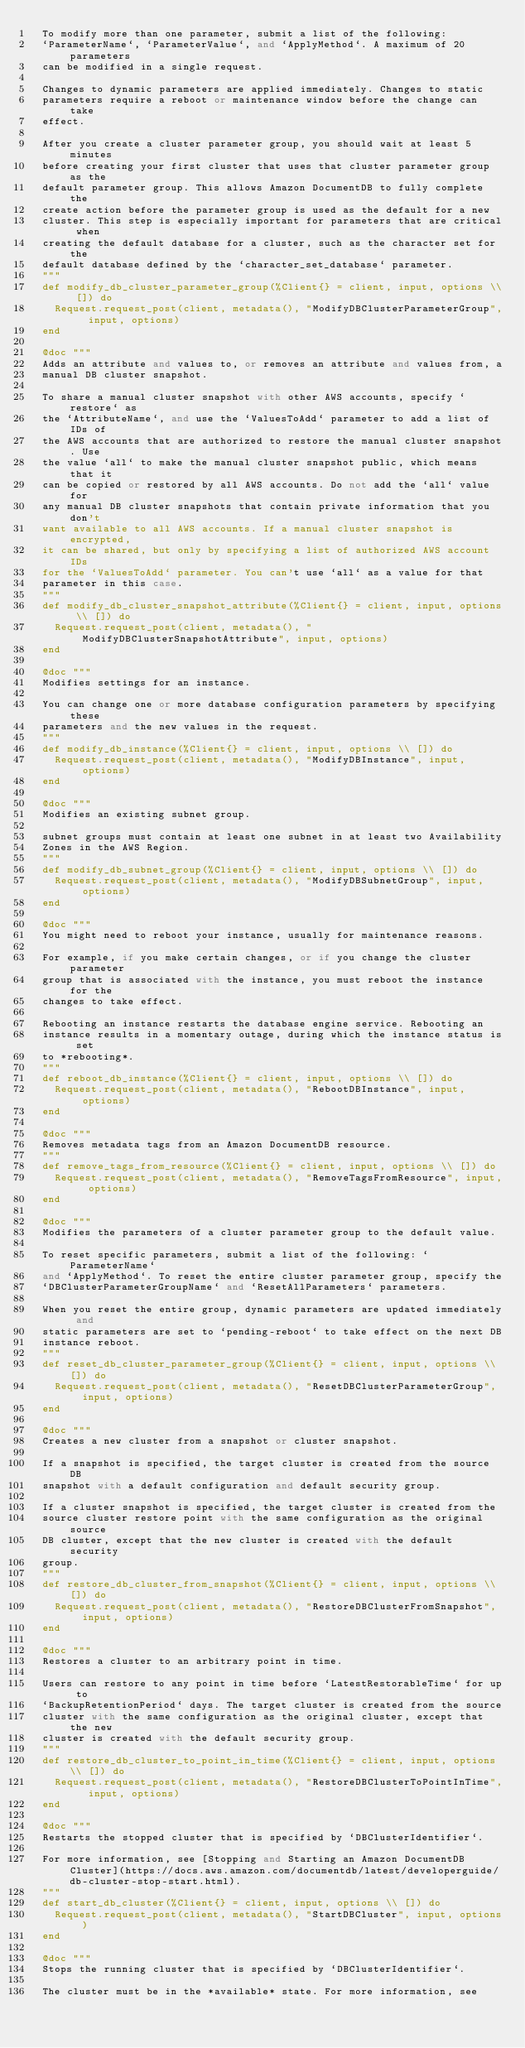Convert code to text. <code><loc_0><loc_0><loc_500><loc_500><_Elixir_>  To modify more than one parameter, submit a list of the following:
  `ParameterName`, `ParameterValue`, and `ApplyMethod`. A maximum of 20 parameters
  can be modified in a single request.

  Changes to dynamic parameters are applied immediately. Changes to static
  parameters require a reboot or maintenance window before the change can take
  effect.

  After you create a cluster parameter group, you should wait at least 5 minutes
  before creating your first cluster that uses that cluster parameter group as the
  default parameter group. This allows Amazon DocumentDB to fully complete the
  create action before the parameter group is used as the default for a new
  cluster. This step is especially important for parameters that are critical when
  creating the default database for a cluster, such as the character set for the
  default database defined by the `character_set_database` parameter.
  """
  def modify_db_cluster_parameter_group(%Client{} = client, input, options \\ []) do
    Request.request_post(client, metadata(), "ModifyDBClusterParameterGroup", input, options)
  end

  @doc """
  Adds an attribute and values to, or removes an attribute and values from, a
  manual DB cluster snapshot.

  To share a manual cluster snapshot with other AWS accounts, specify `restore` as
  the `AttributeName`, and use the `ValuesToAdd` parameter to add a list of IDs of
  the AWS accounts that are authorized to restore the manual cluster snapshot. Use
  the value `all` to make the manual cluster snapshot public, which means that it
  can be copied or restored by all AWS accounts. Do not add the `all` value for
  any manual DB cluster snapshots that contain private information that you don't
  want available to all AWS accounts. If a manual cluster snapshot is encrypted,
  it can be shared, but only by specifying a list of authorized AWS account IDs
  for the `ValuesToAdd` parameter. You can't use `all` as a value for that
  parameter in this case.
  """
  def modify_db_cluster_snapshot_attribute(%Client{} = client, input, options \\ []) do
    Request.request_post(client, metadata(), "ModifyDBClusterSnapshotAttribute", input, options)
  end

  @doc """
  Modifies settings for an instance.

  You can change one or more database configuration parameters by specifying these
  parameters and the new values in the request.
  """
  def modify_db_instance(%Client{} = client, input, options \\ []) do
    Request.request_post(client, metadata(), "ModifyDBInstance", input, options)
  end

  @doc """
  Modifies an existing subnet group.

  subnet groups must contain at least one subnet in at least two Availability
  Zones in the AWS Region.
  """
  def modify_db_subnet_group(%Client{} = client, input, options \\ []) do
    Request.request_post(client, metadata(), "ModifyDBSubnetGroup", input, options)
  end

  @doc """
  You might need to reboot your instance, usually for maintenance reasons.

  For example, if you make certain changes, or if you change the cluster parameter
  group that is associated with the instance, you must reboot the instance for the
  changes to take effect.

  Rebooting an instance restarts the database engine service. Rebooting an
  instance results in a momentary outage, during which the instance status is set
  to *rebooting*.
  """
  def reboot_db_instance(%Client{} = client, input, options \\ []) do
    Request.request_post(client, metadata(), "RebootDBInstance", input, options)
  end

  @doc """
  Removes metadata tags from an Amazon DocumentDB resource.
  """
  def remove_tags_from_resource(%Client{} = client, input, options \\ []) do
    Request.request_post(client, metadata(), "RemoveTagsFromResource", input, options)
  end

  @doc """
  Modifies the parameters of a cluster parameter group to the default value.

  To reset specific parameters, submit a list of the following: `ParameterName`
  and `ApplyMethod`. To reset the entire cluster parameter group, specify the
  `DBClusterParameterGroupName` and `ResetAllParameters` parameters.

  When you reset the entire group, dynamic parameters are updated immediately and
  static parameters are set to `pending-reboot` to take effect on the next DB
  instance reboot.
  """
  def reset_db_cluster_parameter_group(%Client{} = client, input, options \\ []) do
    Request.request_post(client, metadata(), "ResetDBClusterParameterGroup", input, options)
  end

  @doc """
  Creates a new cluster from a snapshot or cluster snapshot.

  If a snapshot is specified, the target cluster is created from the source DB
  snapshot with a default configuration and default security group.

  If a cluster snapshot is specified, the target cluster is created from the
  source cluster restore point with the same configuration as the original source
  DB cluster, except that the new cluster is created with the default security
  group.
  """
  def restore_db_cluster_from_snapshot(%Client{} = client, input, options \\ []) do
    Request.request_post(client, metadata(), "RestoreDBClusterFromSnapshot", input, options)
  end

  @doc """
  Restores a cluster to an arbitrary point in time.

  Users can restore to any point in time before `LatestRestorableTime` for up to
  `BackupRetentionPeriod` days. The target cluster is created from the source
  cluster with the same configuration as the original cluster, except that the new
  cluster is created with the default security group.
  """
  def restore_db_cluster_to_point_in_time(%Client{} = client, input, options \\ []) do
    Request.request_post(client, metadata(), "RestoreDBClusterToPointInTime", input, options)
  end

  @doc """
  Restarts the stopped cluster that is specified by `DBClusterIdentifier`.

  For more information, see [Stopping and Starting an Amazon DocumentDB Cluster](https://docs.aws.amazon.com/documentdb/latest/developerguide/db-cluster-stop-start.html).
  """
  def start_db_cluster(%Client{} = client, input, options \\ []) do
    Request.request_post(client, metadata(), "StartDBCluster", input, options)
  end

  @doc """
  Stops the running cluster that is specified by `DBClusterIdentifier`.

  The cluster must be in the *available* state. For more information, see</code> 